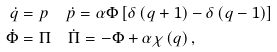<formula> <loc_0><loc_0><loc_500><loc_500>\dot { q } & = p \quad \dot { p } = \alpha \Phi \left [ \delta \left ( q + 1 \right ) - \delta \left ( q - 1 \right ) \right ] \\ \dot { \Phi } & = \Pi \quad \dot { \Pi } = - \Phi + \alpha \chi \left ( q \right ) ,</formula> 